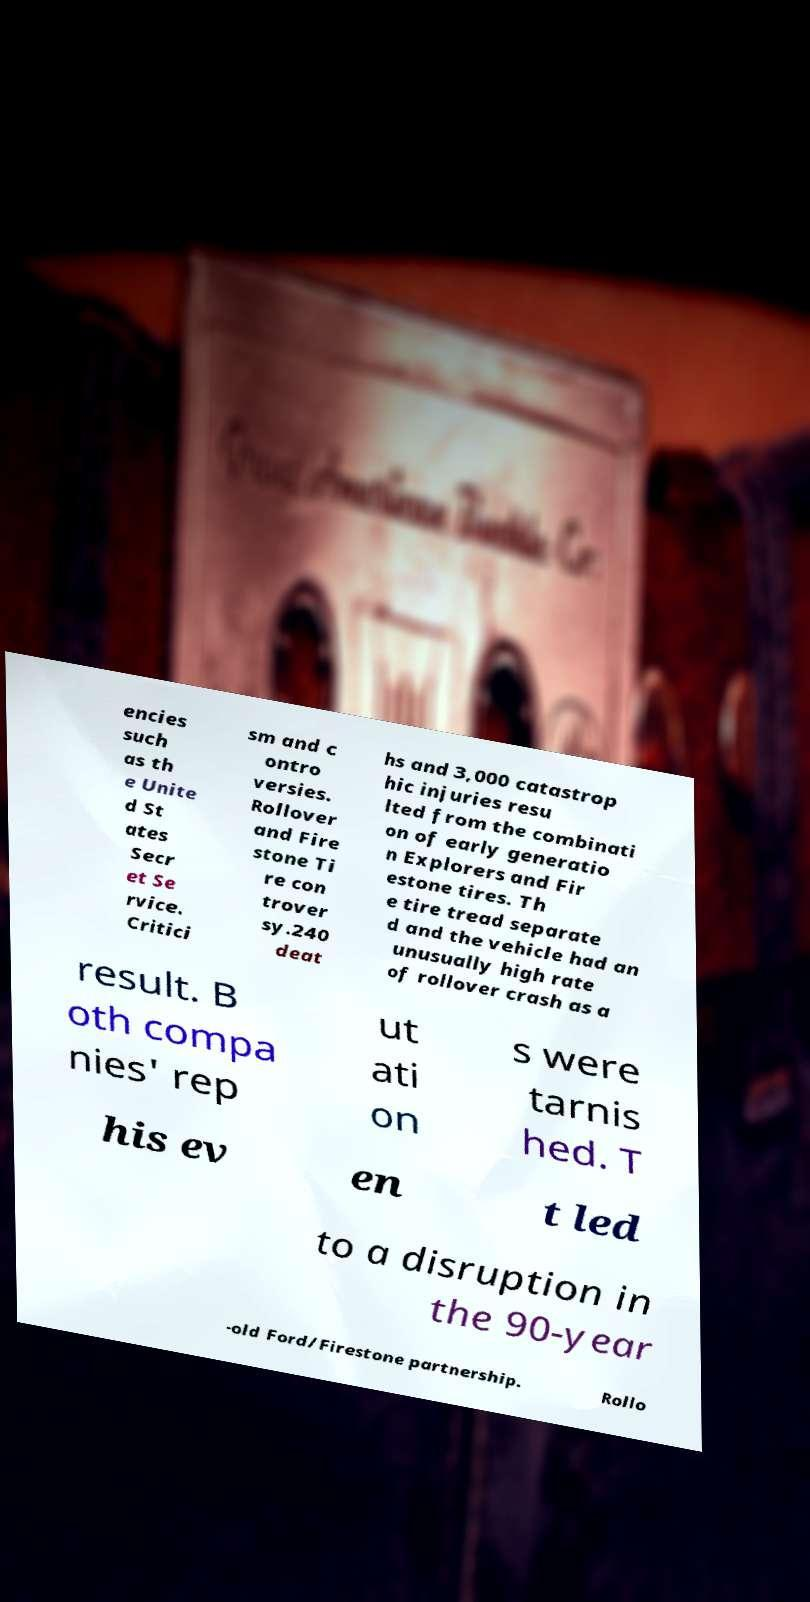Can you accurately transcribe the text from the provided image for me? encies such as th e Unite d St ates Secr et Se rvice. Critici sm and c ontro versies. Rollover and Fire stone Ti re con trover sy.240 deat hs and 3,000 catastrop hic injuries resu lted from the combinati on of early generatio n Explorers and Fir estone tires. Th e tire tread separate d and the vehicle had an unusually high rate of rollover crash as a result. B oth compa nies' rep ut ati on s were tarnis hed. T his ev en t led to a disruption in the 90-year -old Ford/Firestone partnership. Rollo 